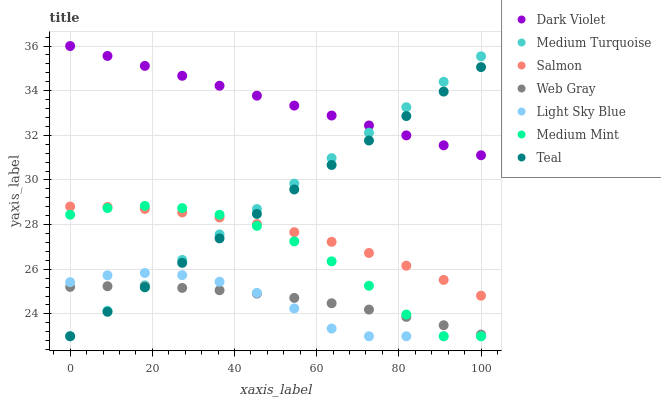Does Light Sky Blue have the minimum area under the curve?
Answer yes or no. Yes. Does Dark Violet have the maximum area under the curve?
Answer yes or no. Yes. Does Web Gray have the minimum area under the curve?
Answer yes or no. No. Does Web Gray have the maximum area under the curve?
Answer yes or no. No. Is Dark Violet the smoothest?
Answer yes or no. Yes. Is Medium Mint the roughest?
Answer yes or no. Yes. Is Web Gray the smoothest?
Answer yes or no. No. Is Web Gray the roughest?
Answer yes or no. No. Does Medium Mint have the lowest value?
Answer yes or no. Yes. Does Web Gray have the lowest value?
Answer yes or no. No. Does Dark Violet have the highest value?
Answer yes or no. Yes. Does Teal have the highest value?
Answer yes or no. No. Is Medium Mint less than Dark Violet?
Answer yes or no. Yes. Is Dark Violet greater than Light Sky Blue?
Answer yes or no. Yes. Does Light Sky Blue intersect Teal?
Answer yes or no. Yes. Is Light Sky Blue less than Teal?
Answer yes or no. No. Is Light Sky Blue greater than Teal?
Answer yes or no. No. Does Medium Mint intersect Dark Violet?
Answer yes or no. No. 